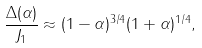<formula> <loc_0><loc_0><loc_500><loc_500>\frac { \Delta ( \alpha ) } { J _ { 1 } } \approx ( 1 - \alpha ) ^ { 3 / 4 } ( 1 + \alpha ) ^ { 1 / 4 } ,</formula> 